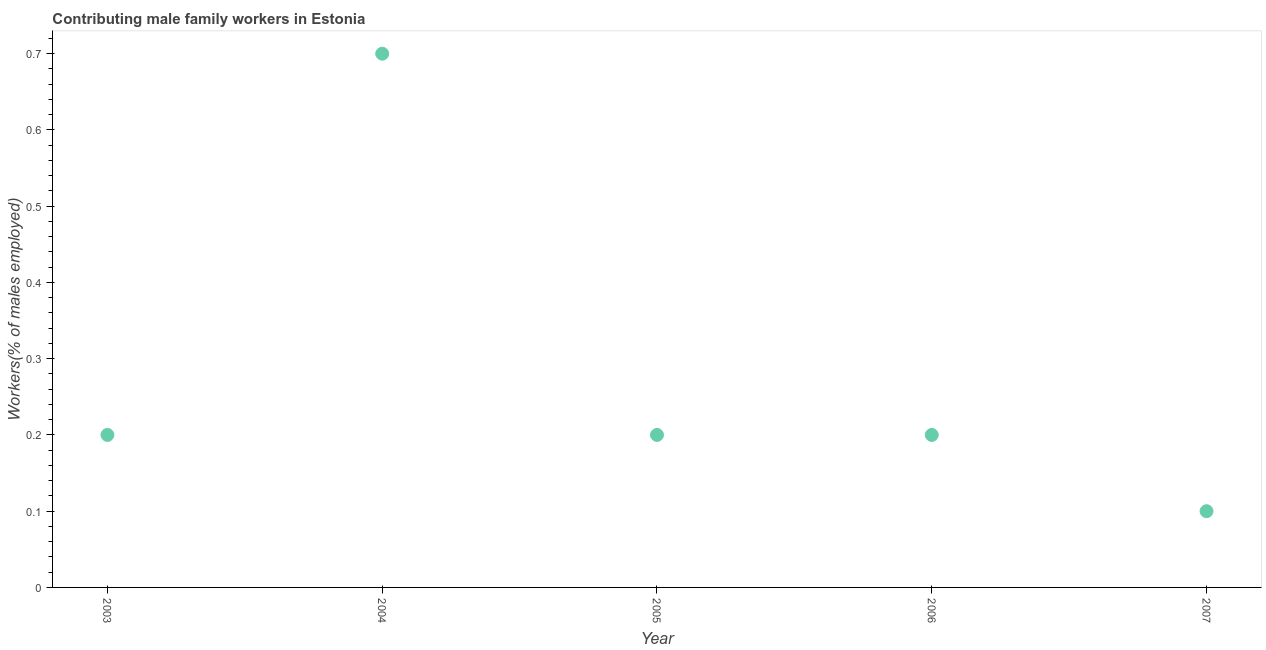What is the contributing male family workers in 2007?
Your response must be concise. 0.1. Across all years, what is the maximum contributing male family workers?
Give a very brief answer. 0.7. Across all years, what is the minimum contributing male family workers?
Your answer should be compact. 0.1. In which year was the contributing male family workers maximum?
Keep it short and to the point. 2004. In which year was the contributing male family workers minimum?
Ensure brevity in your answer.  2007. What is the sum of the contributing male family workers?
Give a very brief answer. 1.4. What is the difference between the contributing male family workers in 2004 and 2006?
Make the answer very short. 0.5. What is the average contributing male family workers per year?
Your answer should be compact. 0.28. What is the median contributing male family workers?
Keep it short and to the point. 0.2. Do a majority of the years between 2005 and 2007 (inclusive) have contributing male family workers greater than 0.26 %?
Your answer should be compact. No. Is the difference between the contributing male family workers in 2005 and 2006 greater than the difference between any two years?
Ensure brevity in your answer.  No. What is the difference between the highest and the second highest contributing male family workers?
Give a very brief answer. 0.5. What is the difference between the highest and the lowest contributing male family workers?
Give a very brief answer. 0.6. In how many years, is the contributing male family workers greater than the average contributing male family workers taken over all years?
Offer a very short reply. 1. What is the difference between two consecutive major ticks on the Y-axis?
Offer a terse response. 0.1. Does the graph contain any zero values?
Make the answer very short. No. Does the graph contain grids?
Offer a very short reply. No. What is the title of the graph?
Provide a short and direct response. Contributing male family workers in Estonia. What is the label or title of the X-axis?
Keep it short and to the point. Year. What is the label or title of the Y-axis?
Give a very brief answer. Workers(% of males employed). What is the Workers(% of males employed) in 2003?
Your answer should be compact. 0.2. What is the Workers(% of males employed) in 2004?
Provide a succinct answer. 0.7. What is the Workers(% of males employed) in 2005?
Provide a short and direct response. 0.2. What is the Workers(% of males employed) in 2006?
Your answer should be very brief. 0.2. What is the Workers(% of males employed) in 2007?
Provide a short and direct response. 0.1. What is the difference between the Workers(% of males employed) in 2003 and 2004?
Ensure brevity in your answer.  -0.5. What is the difference between the Workers(% of males employed) in 2003 and 2005?
Your answer should be compact. 0. What is the difference between the Workers(% of males employed) in 2006 and 2007?
Make the answer very short. 0.1. What is the ratio of the Workers(% of males employed) in 2003 to that in 2004?
Give a very brief answer. 0.29. What is the ratio of the Workers(% of males employed) in 2003 to that in 2005?
Offer a very short reply. 1. What is the ratio of the Workers(% of males employed) in 2004 to that in 2005?
Ensure brevity in your answer.  3.5. What is the ratio of the Workers(% of males employed) in 2004 to that in 2007?
Ensure brevity in your answer.  7. What is the ratio of the Workers(% of males employed) in 2005 to that in 2007?
Offer a very short reply. 2. What is the ratio of the Workers(% of males employed) in 2006 to that in 2007?
Provide a short and direct response. 2. 